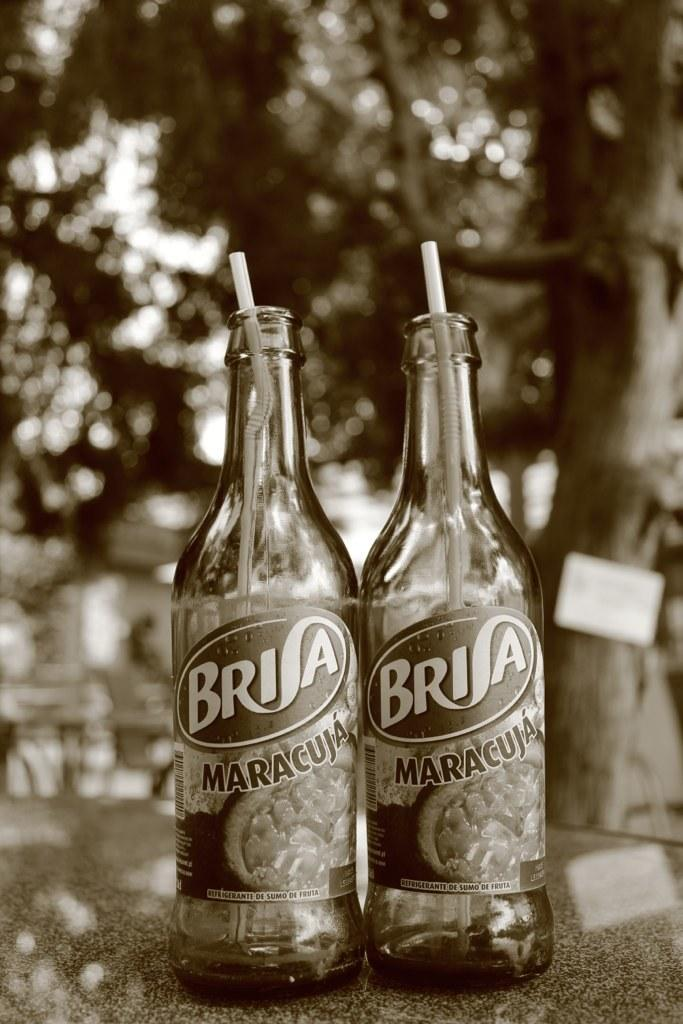<image>
Present a compact description of the photo's key features. Two bottles of Brisa Maracuja sit next to each other with straws in them. 